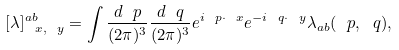Convert formula to latex. <formula><loc_0><loc_0><loc_500><loc_500>[ \lambda ] ^ { a b } _ { \ x , \ y } = \int { \frac { d \ p } { ( 2 \pi ) ^ { 3 } } } { \frac { d \ q } { ( 2 \pi ) ^ { 3 } } } e ^ { i \ p \cdot \ x } e ^ { - i \ q \cdot \ y } \lambda _ { a b } ( \ p , \ q ) ,</formula> 